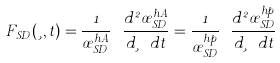<formula> <loc_0><loc_0><loc_500><loc_500>F _ { S D } ( \xi , t ) = \frac { 1 } { \sigma _ { S D } ^ { h A } } \ \frac { d ^ { 2 } \sigma _ { S D } ^ { h A } } { d \xi \ d t } = \frac { 1 } { \sigma _ { S D } ^ { h p } } \ \frac { d ^ { 2 } \sigma _ { S D } ^ { h p } } { d \xi \ d t }</formula> 